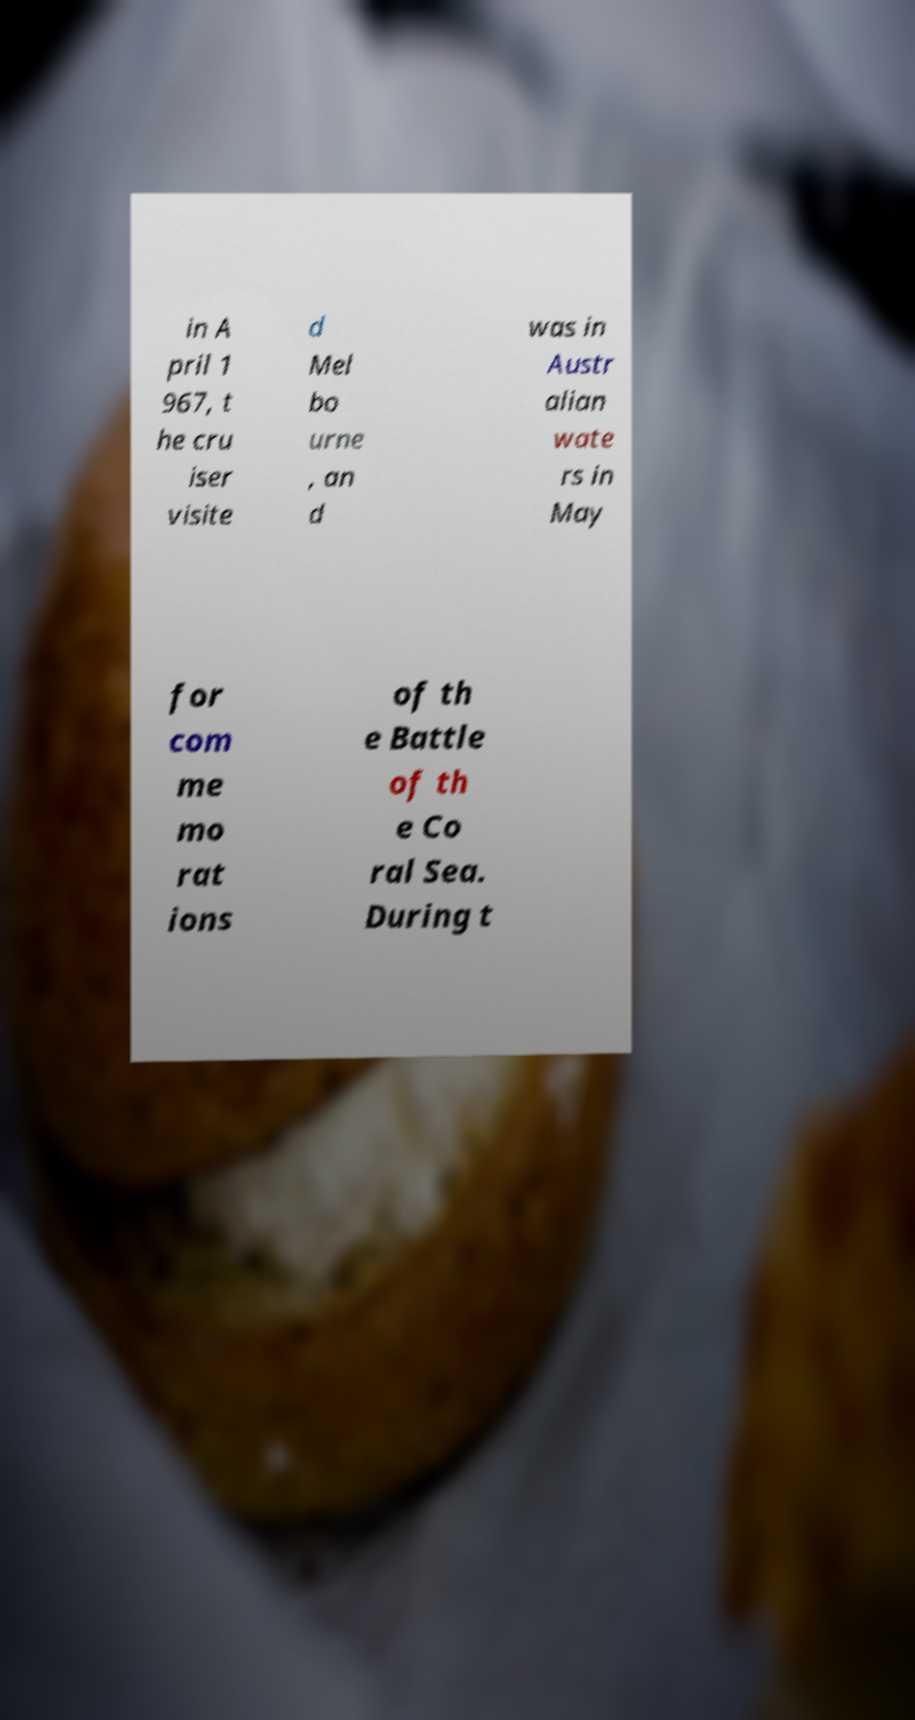There's text embedded in this image that I need extracted. Can you transcribe it verbatim? in A pril 1 967, t he cru iser visite d Mel bo urne , an d was in Austr alian wate rs in May for com me mo rat ions of th e Battle of th e Co ral Sea. During t 